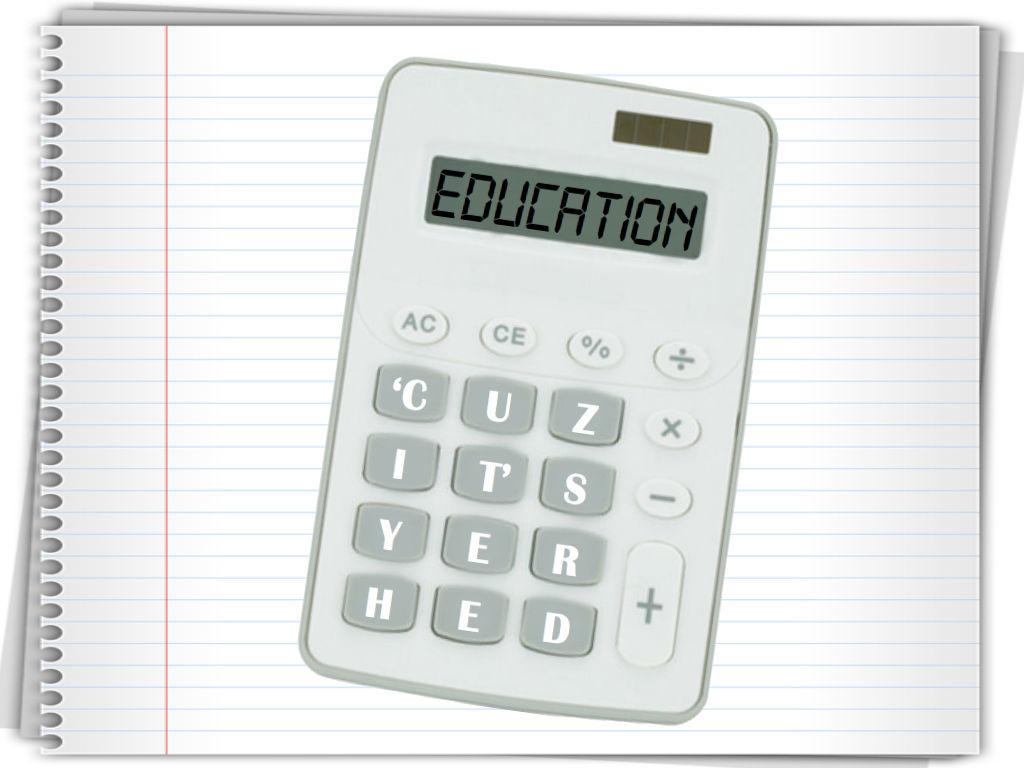<image>
Summarize the visual content of the image. A calculation graphic sitting on a a piece of notebook paper says EDUCATION in the number readout area. 